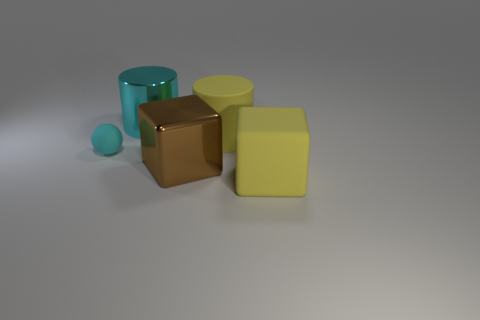How many matte cylinders are there?
Provide a succinct answer. 1. There is a big cylinder on the left side of the yellow cylinder; what is its color?
Provide a succinct answer. Cyan. The big matte thing that is to the right of the yellow rubber object that is behind the tiny object is what color?
Provide a short and direct response. Yellow. There is a matte cylinder that is the same size as the brown block; what is its color?
Ensure brevity in your answer.  Yellow. How many things are both behind the brown object and on the right side of the rubber sphere?
Make the answer very short. 2. The object that is the same color as the large matte cube is what shape?
Your answer should be compact. Cylinder. There is a thing that is on the right side of the large brown cube and in front of the small thing; what is its material?
Make the answer very short. Rubber. Are there fewer large things to the right of the yellow cylinder than rubber objects to the right of the brown block?
Give a very brief answer. Yes. There is a yellow object that is made of the same material as the yellow cube; what is its size?
Keep it short and to the point. Large. Are there any other things of the same color as the shiny cube?
Give a very brief answer. No. 